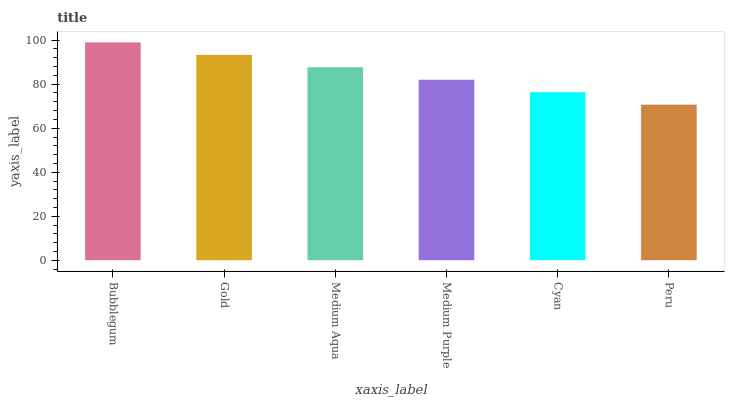Is Gold the minimum?
Answer yes or no. No. Is Gold the maximum?
Answer yes or no. No. Is Bubblegum greater than Gold?
Answer yes or no. Yes. Is Gold less than Bubblegum?
Answer yes or no. Yes. Is Gold greater than Bubblegum?
Answer yes or no. No. Is Bubblegum less than Gold?
Answer yes or no. No. Is Medium Aqua the high median?
Answer yes or no. Yes. Is Medium Purple the low median?
Answer yes or no. Yes. Is Gold the high median?
Answer yes or no. No. Is Gold the low median?
Answer yes or no. No. 